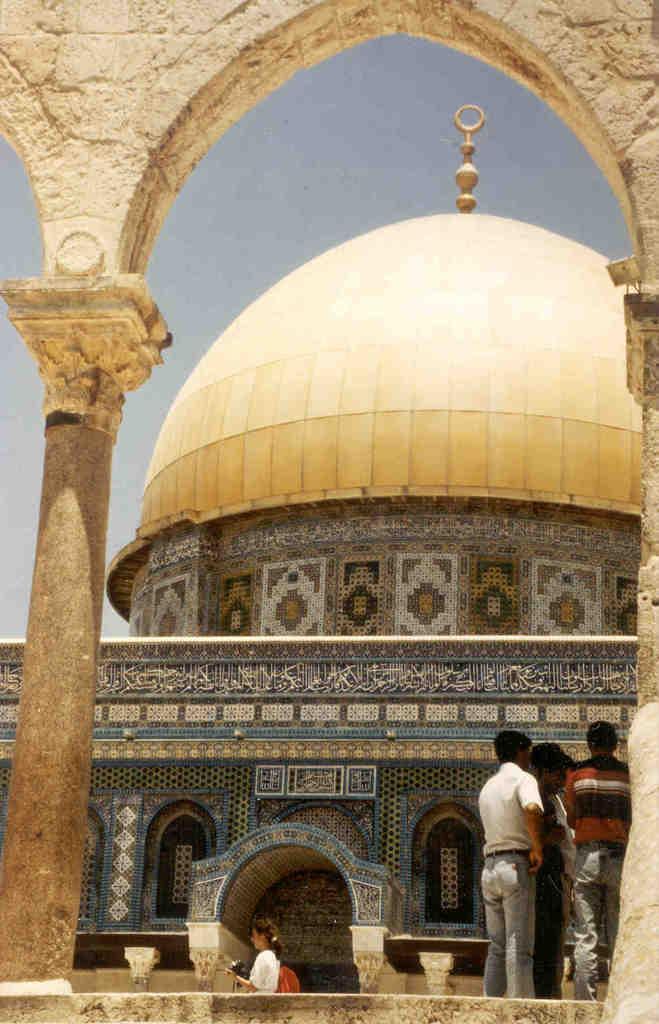Describe this image in one or two sentences. In this image in the center there is one mosque and there are some people, in the foreground there are some pillars and wall. On the top of the image there is sky. 